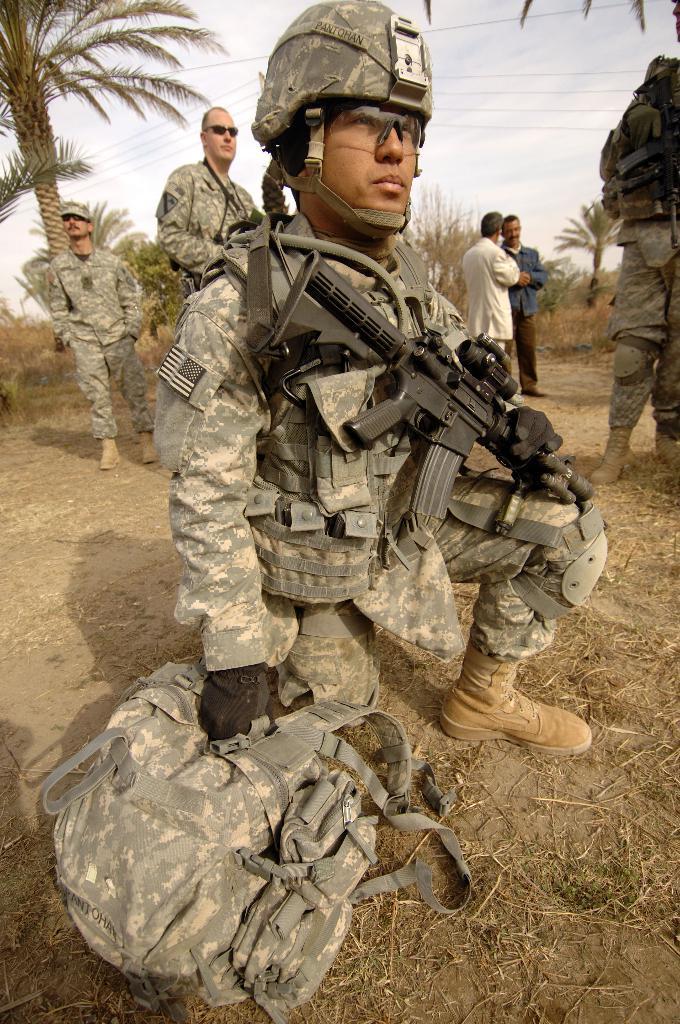In one or two sentences, can you explain what this image depicts? This image is taken outdoors. At the bottom of the image there is a ground. At the top of the image there is a sky with clouds. In the background there are a few trees and plants. In the middle of the image a few men are standing on the ground and they are holding guns in their hands and a man is in a squatting position and he is holding a bag and a gun in his hands. 